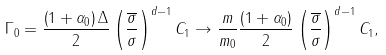<formula> <loc_0><loc_0><loc_500><loc_500>\Gamma _ { 0 } = \frac { \left ( 1 + \alpha _ { 0 } \right ) \Delta } { 2 } \left ( \frac { \overline { \sigma } } { \sigma } \right ) ^ { d - 1 } C _ { 1 } \rightarrow \frac { m } { m _ { 0 } } \frac { \left ( 1 + \alpha _ { 0 } \right ) } { 2 } \left ( \frac { \overline { \sigma } } { \sigma } \right ) ^ { d - 1 } C _ { 1 } ,</formula> 